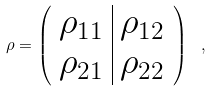Convert formula to latex. <formula><loc_0><loc_0><loc_500><loc_500>\rho = \left ( \begin{array} { c | c } \rho _ { 1 1 } & \rho _ { 1 2 } \\ \rho _ { 2 1 } & \rho _ { 2 2 } \end{array} \right ) \ ,</formula> 